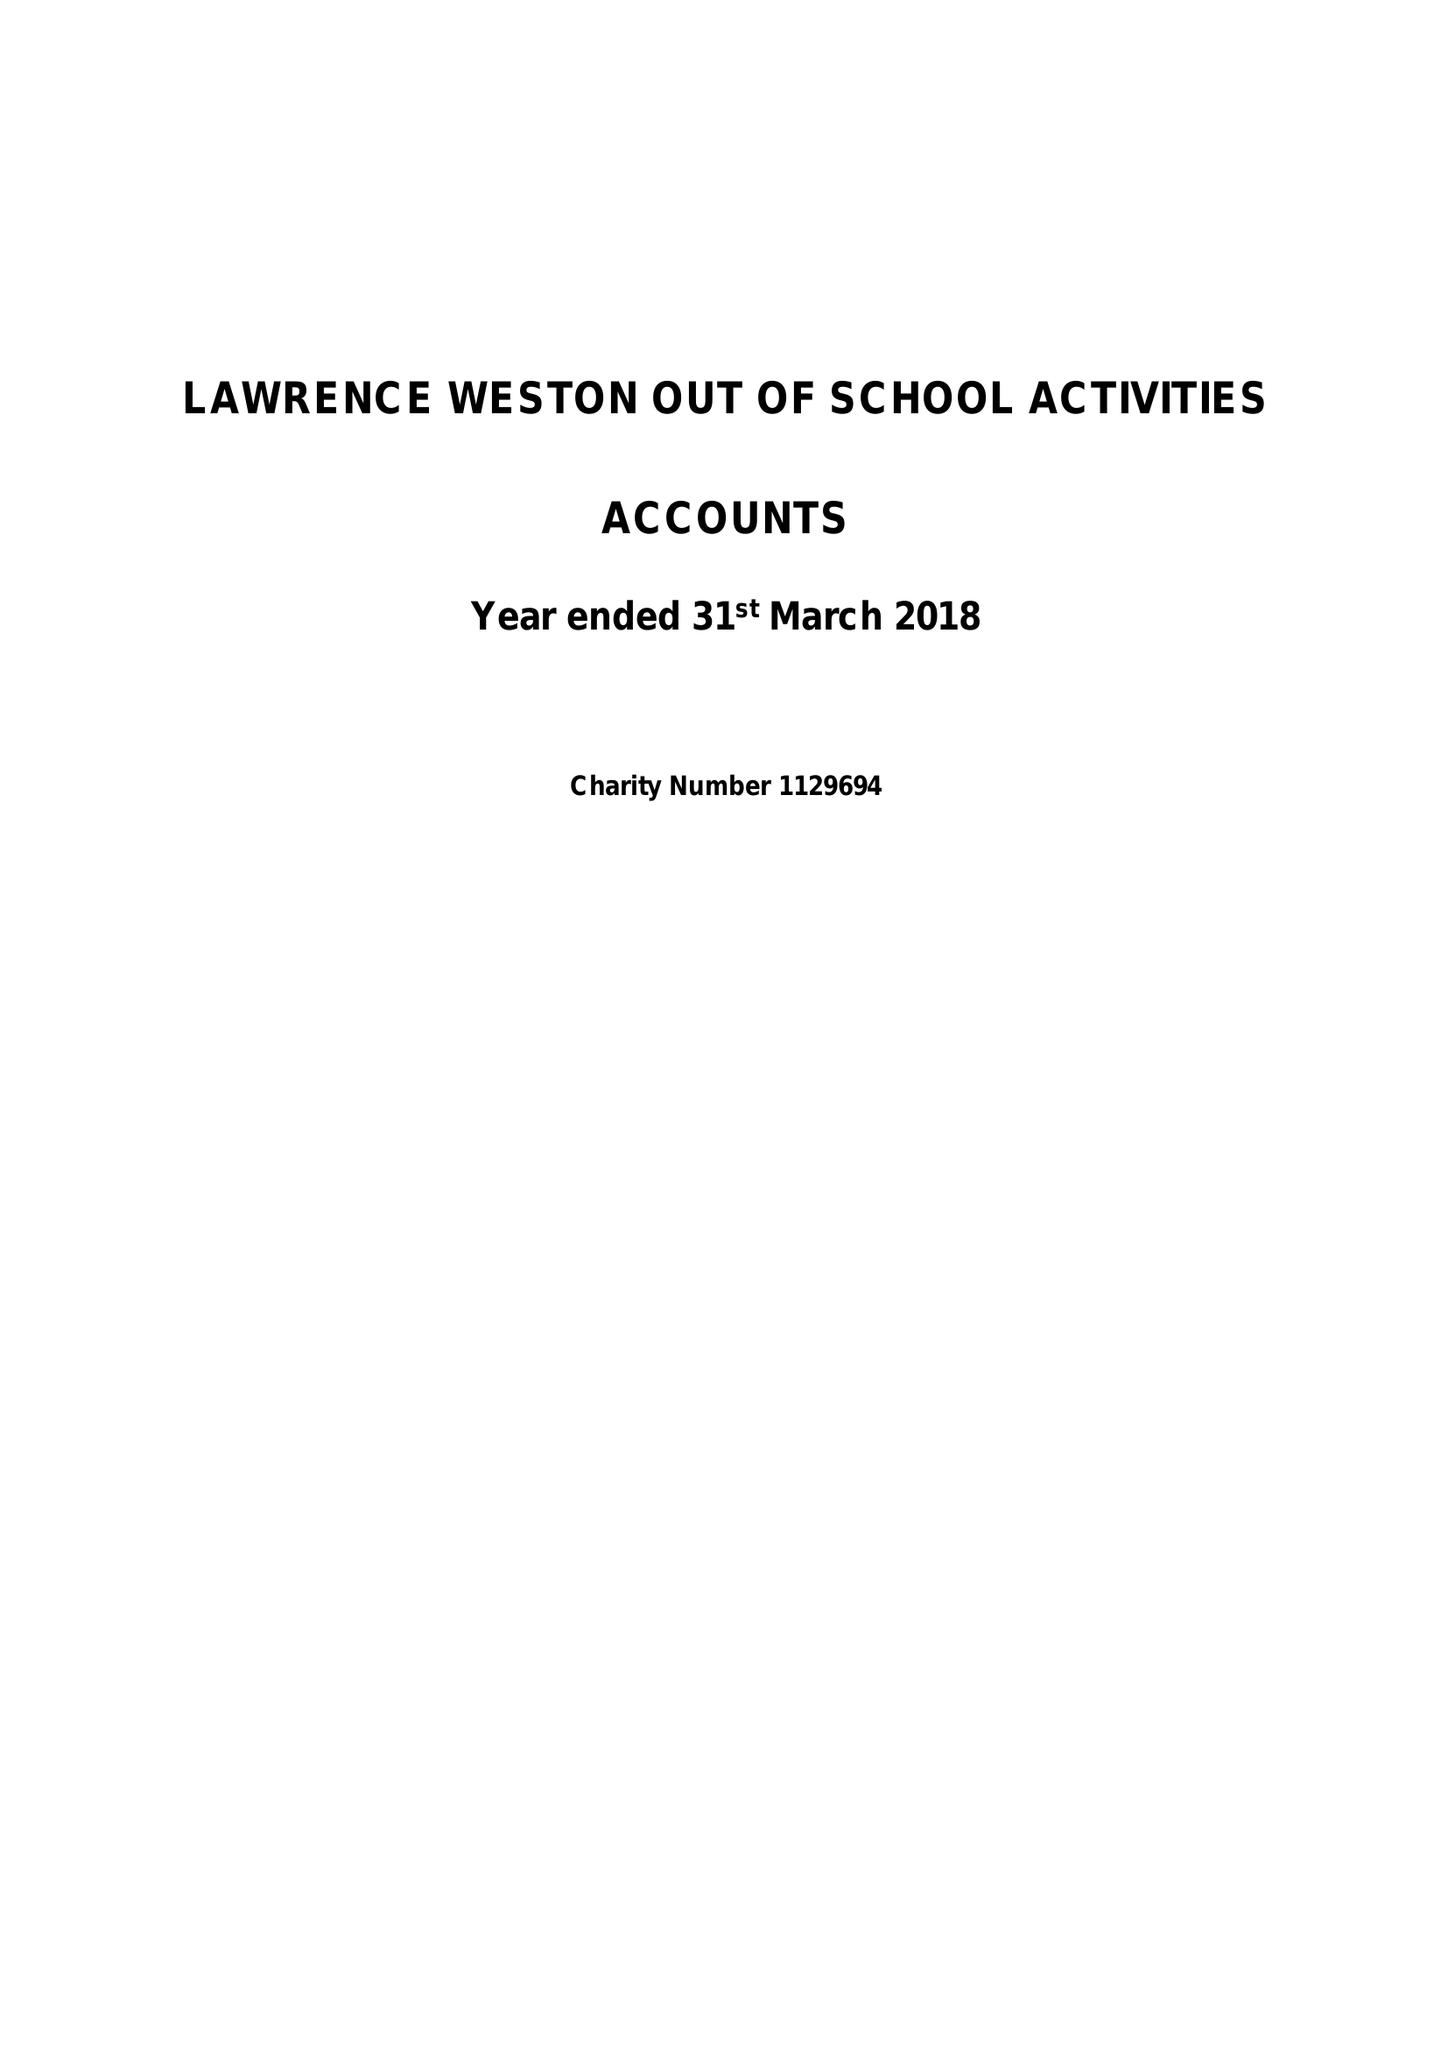What is the value for the spending_annually_in_british_pounds?
Answer the question using a single word or phrase. 83297.00 